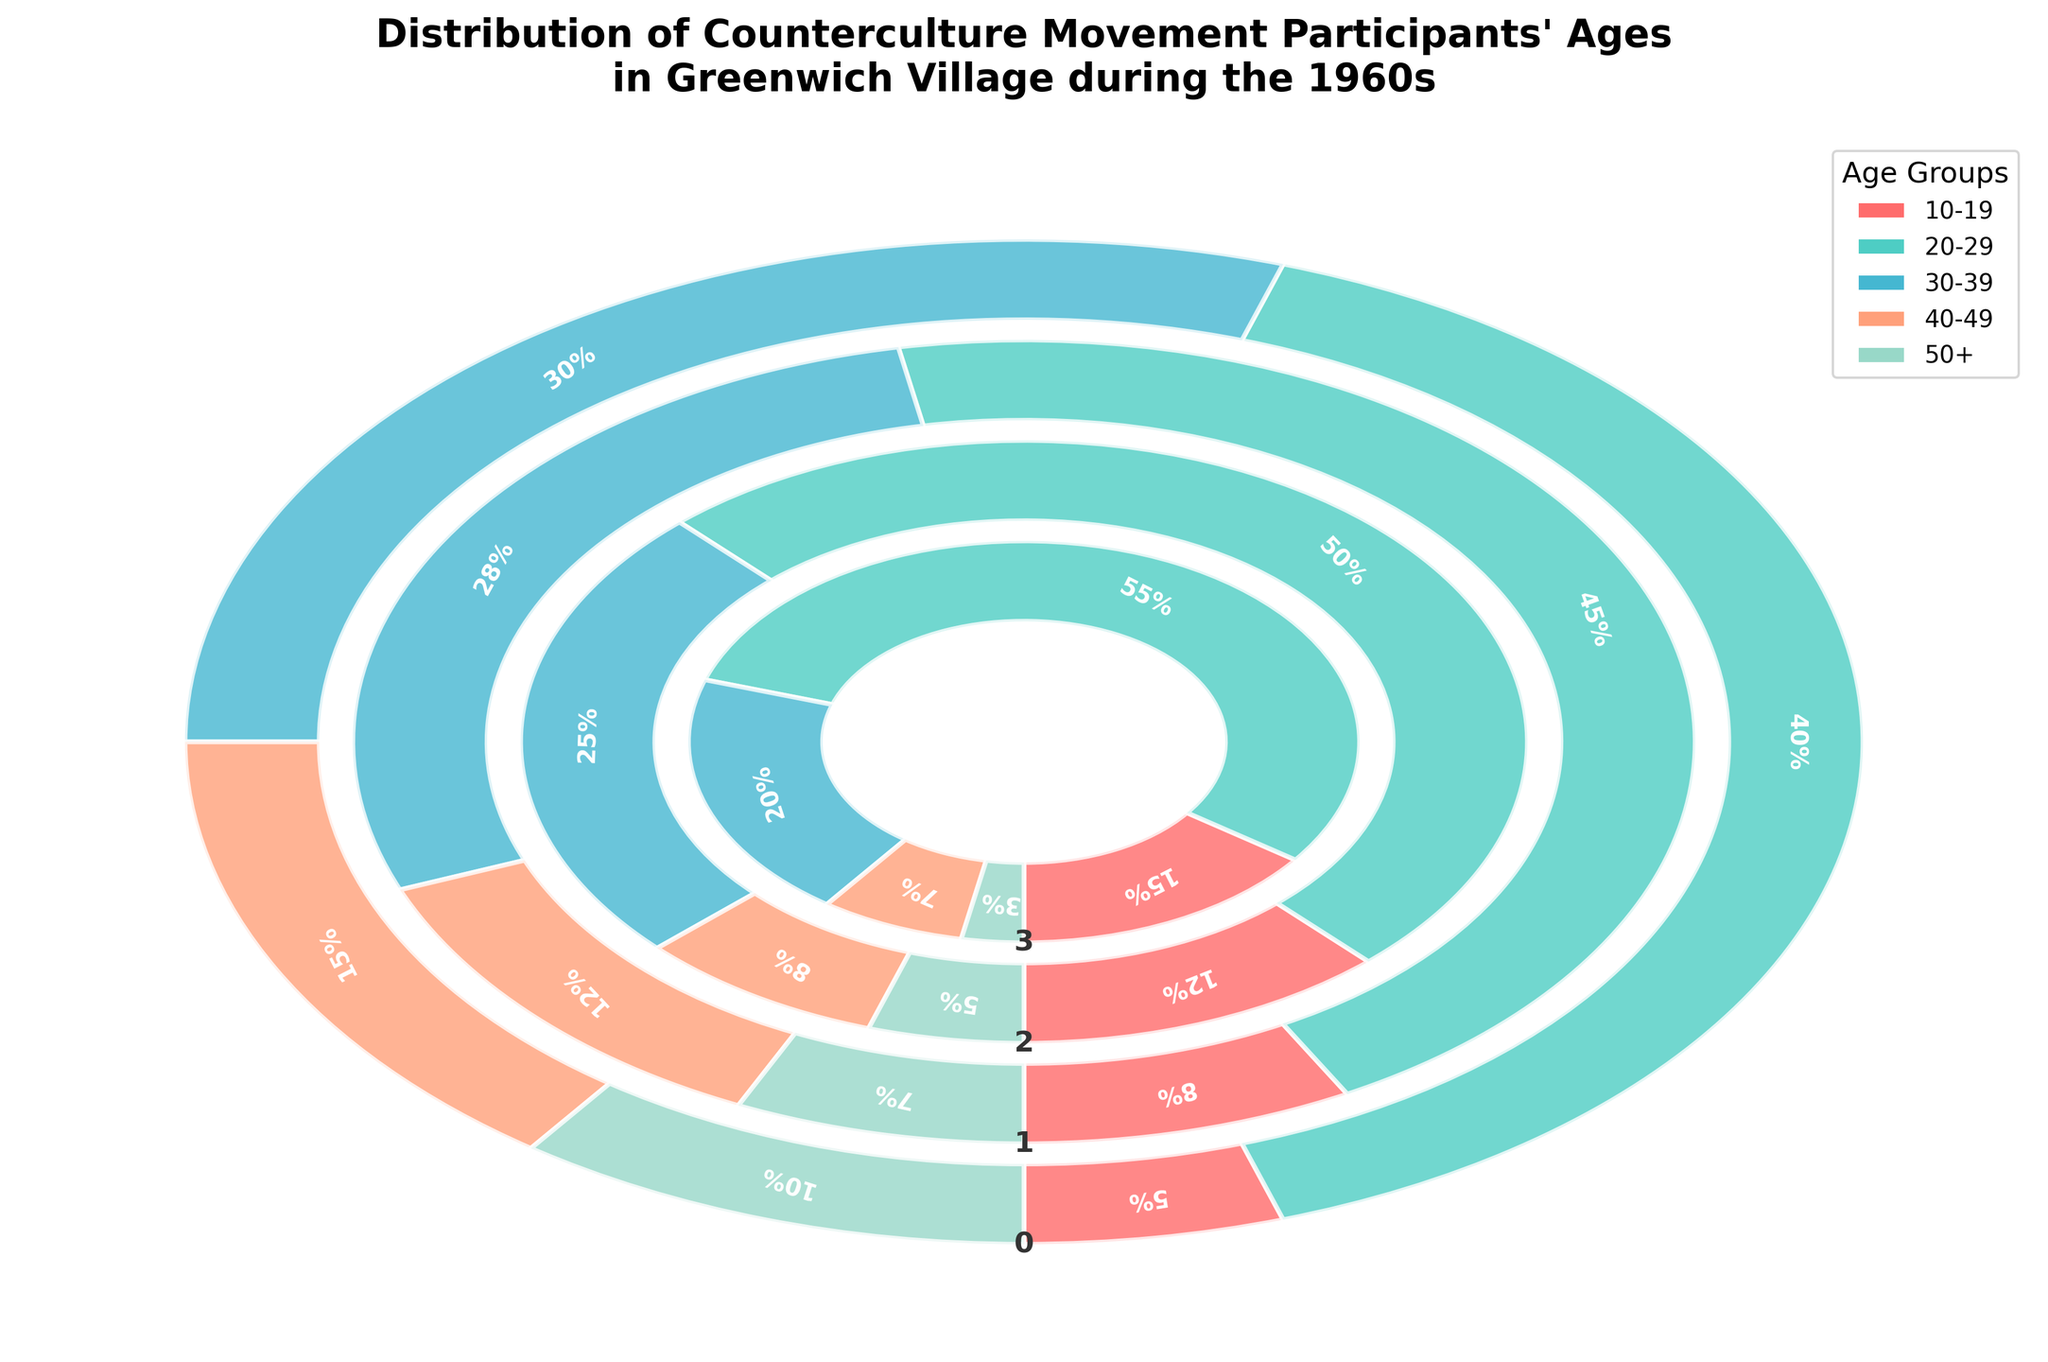What year does the plot show the largest percentage of participants aged 20-29? The year with the largest percentage for the age group 20-29 can be identified by comparing the segments in each year's fan chart. The largest percentage is found in 1969 at 55%.
Answer: 1969 What is the total percentage of participants aged 10-19 in the 1960s? Sum the percentages of the 10-19 age group for each year (1960, 1963, 1966, 1969): 5% + 8% + 12% + 15% = 40%.
Answer: 40% Which age group generally shows a decreasing trend in participation over the 1960s? By observing the direction of the segments over the years 1960, 1963, 1966, and 1969, the age group 40-49 steadily reduces its percentage: 15%, 12%, 8%, 7%.
Answer: 40-49 How does the percentage of participants aged 50+ in 1960 compare to 1969? Compare the segments for the 50+ age group in 1960 and 1969: 10% in 1960 and 3% in 1969, showing a significant decrease.
Answer: 50+ decreased What is the difference in the percentage of participants aged 30-39 between 1960 and 1969? Subtract the 30-39 age group percentage in 1969 from the percentage in 1960: 30% - 20% = 10%.
Answer: 10% Which year had the smallest percentage of participants aged 50+? Examine each year's fan chart for the 50+ age group and determine the smallest segment, which is in 1969 with 3%.
Answer: 1969 What trend can be observed for the age group 20-29 from 1960 to 1969? Observing the fan chart, the percentage for the age group 20-29 increases each year: from 40% in 1960 to 55% in 1969, showing an upward trend.
Answer: Upward trend If the combined percentage of participants for all age groups in 1963 is considered, what is the result? Add the percentages for all age groups in the year 1963: 8% + 45% + 28% + 12% + 7% = 100%.
Answer: 100% What is the general pattern observed for the age group 10-19 over the years? The percentage of participants aged 10-19 increases gradually from 1960 (5%) to 1969 (15%), showing a consistent rise.
Answer: Increasing In which year(s) did participants aged 30-39 constitute exactly one-quarter of the population? Identify the year where the 30-39 age group makes up 25%. This occurs in 1966 only.
Answer: 1966 